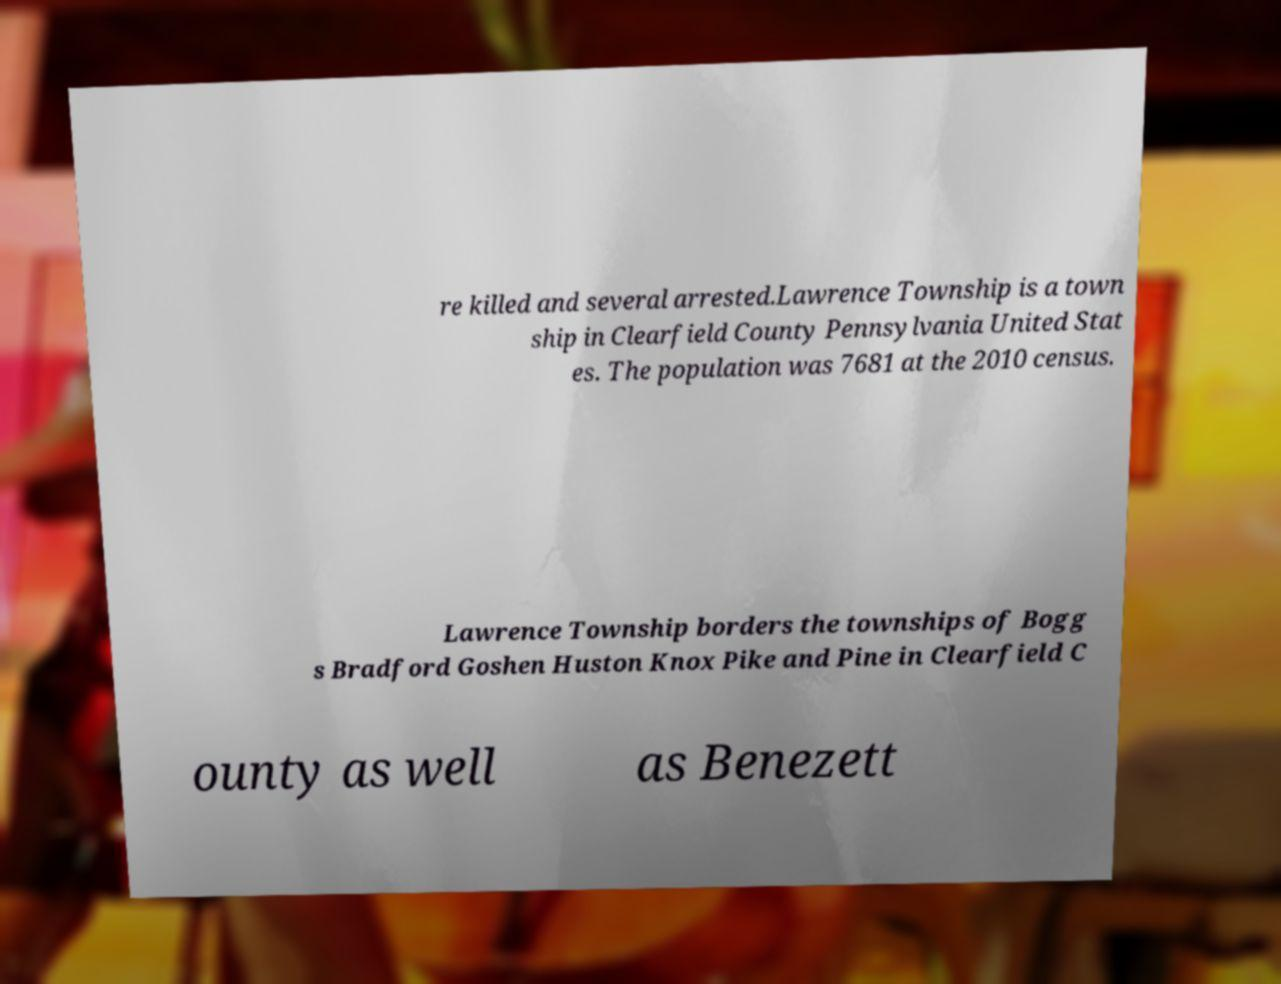There's text embedded in this image that I need extracted. Can you transcribe it verbatim? re killed and several arrested.Lawrence Township is a town ship in Clearfield County Pennsylvania United Stat es. The population was 7681 at the 2010 census. Lawrence Township borders the townships of Bogg s Bradford Goshen Huston Knox Pike and Pine in Clearfield C ounty as well as Benezett 